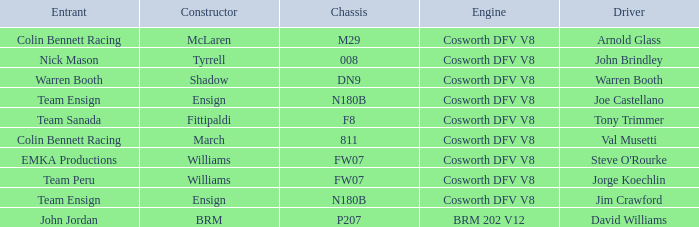What team uses a Cosworth DFV V8 engine and DN9 Chassis? Warren Booth. 